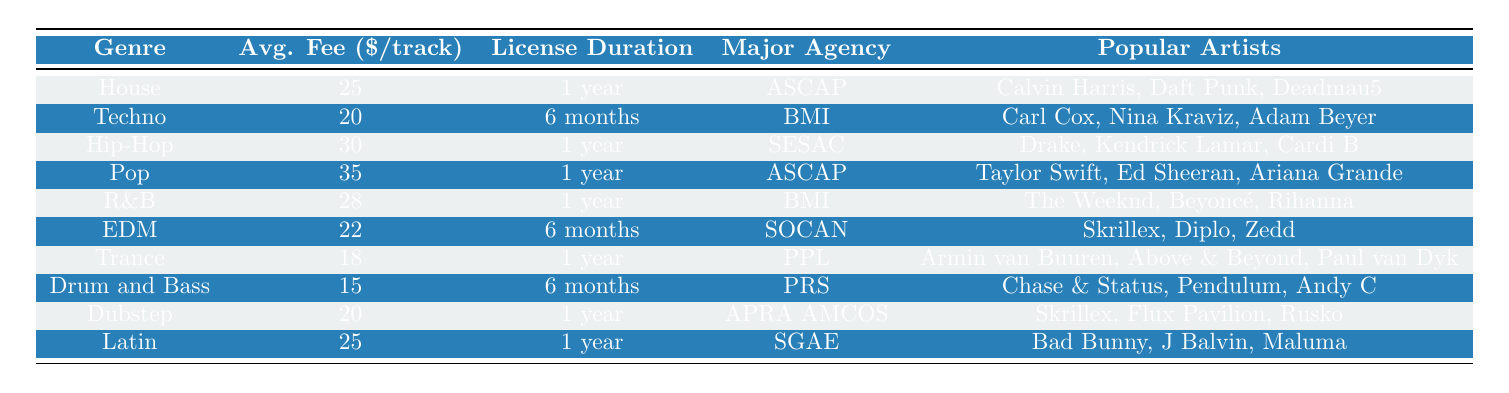What is the average licensing fee for the Pop genre? The table shows the average licensing fee for the Pop genre is $35.
Answer: $35 Which genre has the lowest average licensing fee? The table indicates that Drum and Bass has the lowest average licensing fee at $15.
Answer: Drum and Bass How long is the typical license duration for Techno music? The table states that the typical license duration for Techno music is 6 months.
Answer: 6 months Is the major licensing agency for R&B music ASCAP? The table shows that the major licensing agency for R&B music is BMI, so the statement is false.
Answer: No What is the difference in average licensing fees between Hip-Hop and EDM? The average licensing fee for Hip-Hop is $30, and for EDM, it is $22. The difference is $30 - $22 = $8.
Answer: $8 Which genre has a license duration typically longer than 6 months? According to the table, genres with a license duration of 1 year include House, Hip-Hop, Pop, R&B, Trance, Dubstep, and Latin.
Answer: House, Hip-Hop, Pop, R&B, Trance, Dubstep, Latin What are the popular artists associated with the genre Dubstep? The table lists Skrillex, Flux Pavilion, and Rusko as popular artists in the Dubstep genre.
Answer: Skrillex, Flux Pavilion, Rusko Which genre is associated with the major licensing agency SESAC? The table indicates that Hip-Hop is associated with the major licensing agency SESAC.
Answer: Hip-Hop How many genres have an average licensing fee of 25 or more dollars? The genres with fees of 25 or more are House, Hip-Hop, Pop, R&B, and Latin, totaling 5 genres.
Answer: 5 What is the average licensing fee for genres that have a license duration of 1 year? The average licensing fees are House ($25), Hip-Hop ($30), Pop ($35), R&B ($28), Trance ($18), Dubstep ($20), and Latin ($25). The sum is $25 + $30 + $35 + $28 + $18 + $20 + $25 = $181; dividing by 7 gives an average of $25.86.
Answer: $25.86 